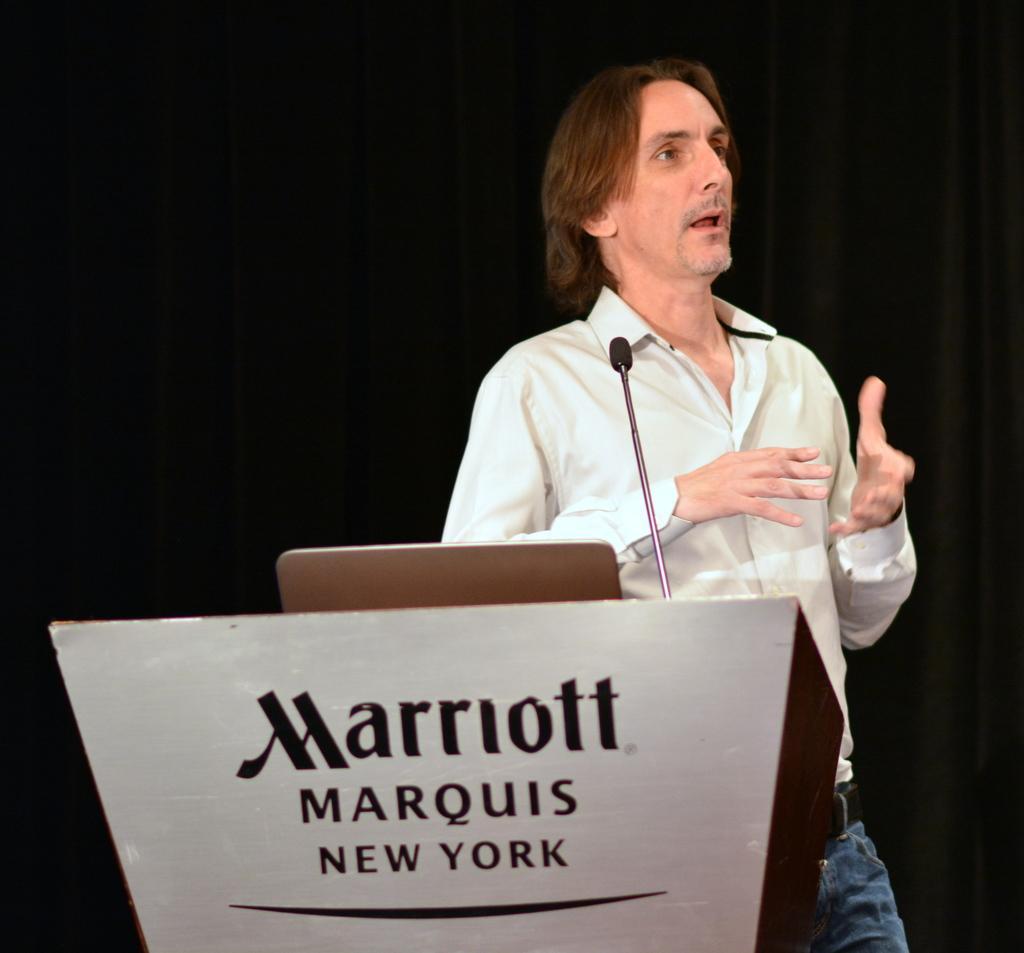In one or two sentences, can you explain what this image depicts? In this image there is a podium on which text is written, there is an object on the podium, there is a microphone, there is a person talking, the background of the image is dark. 